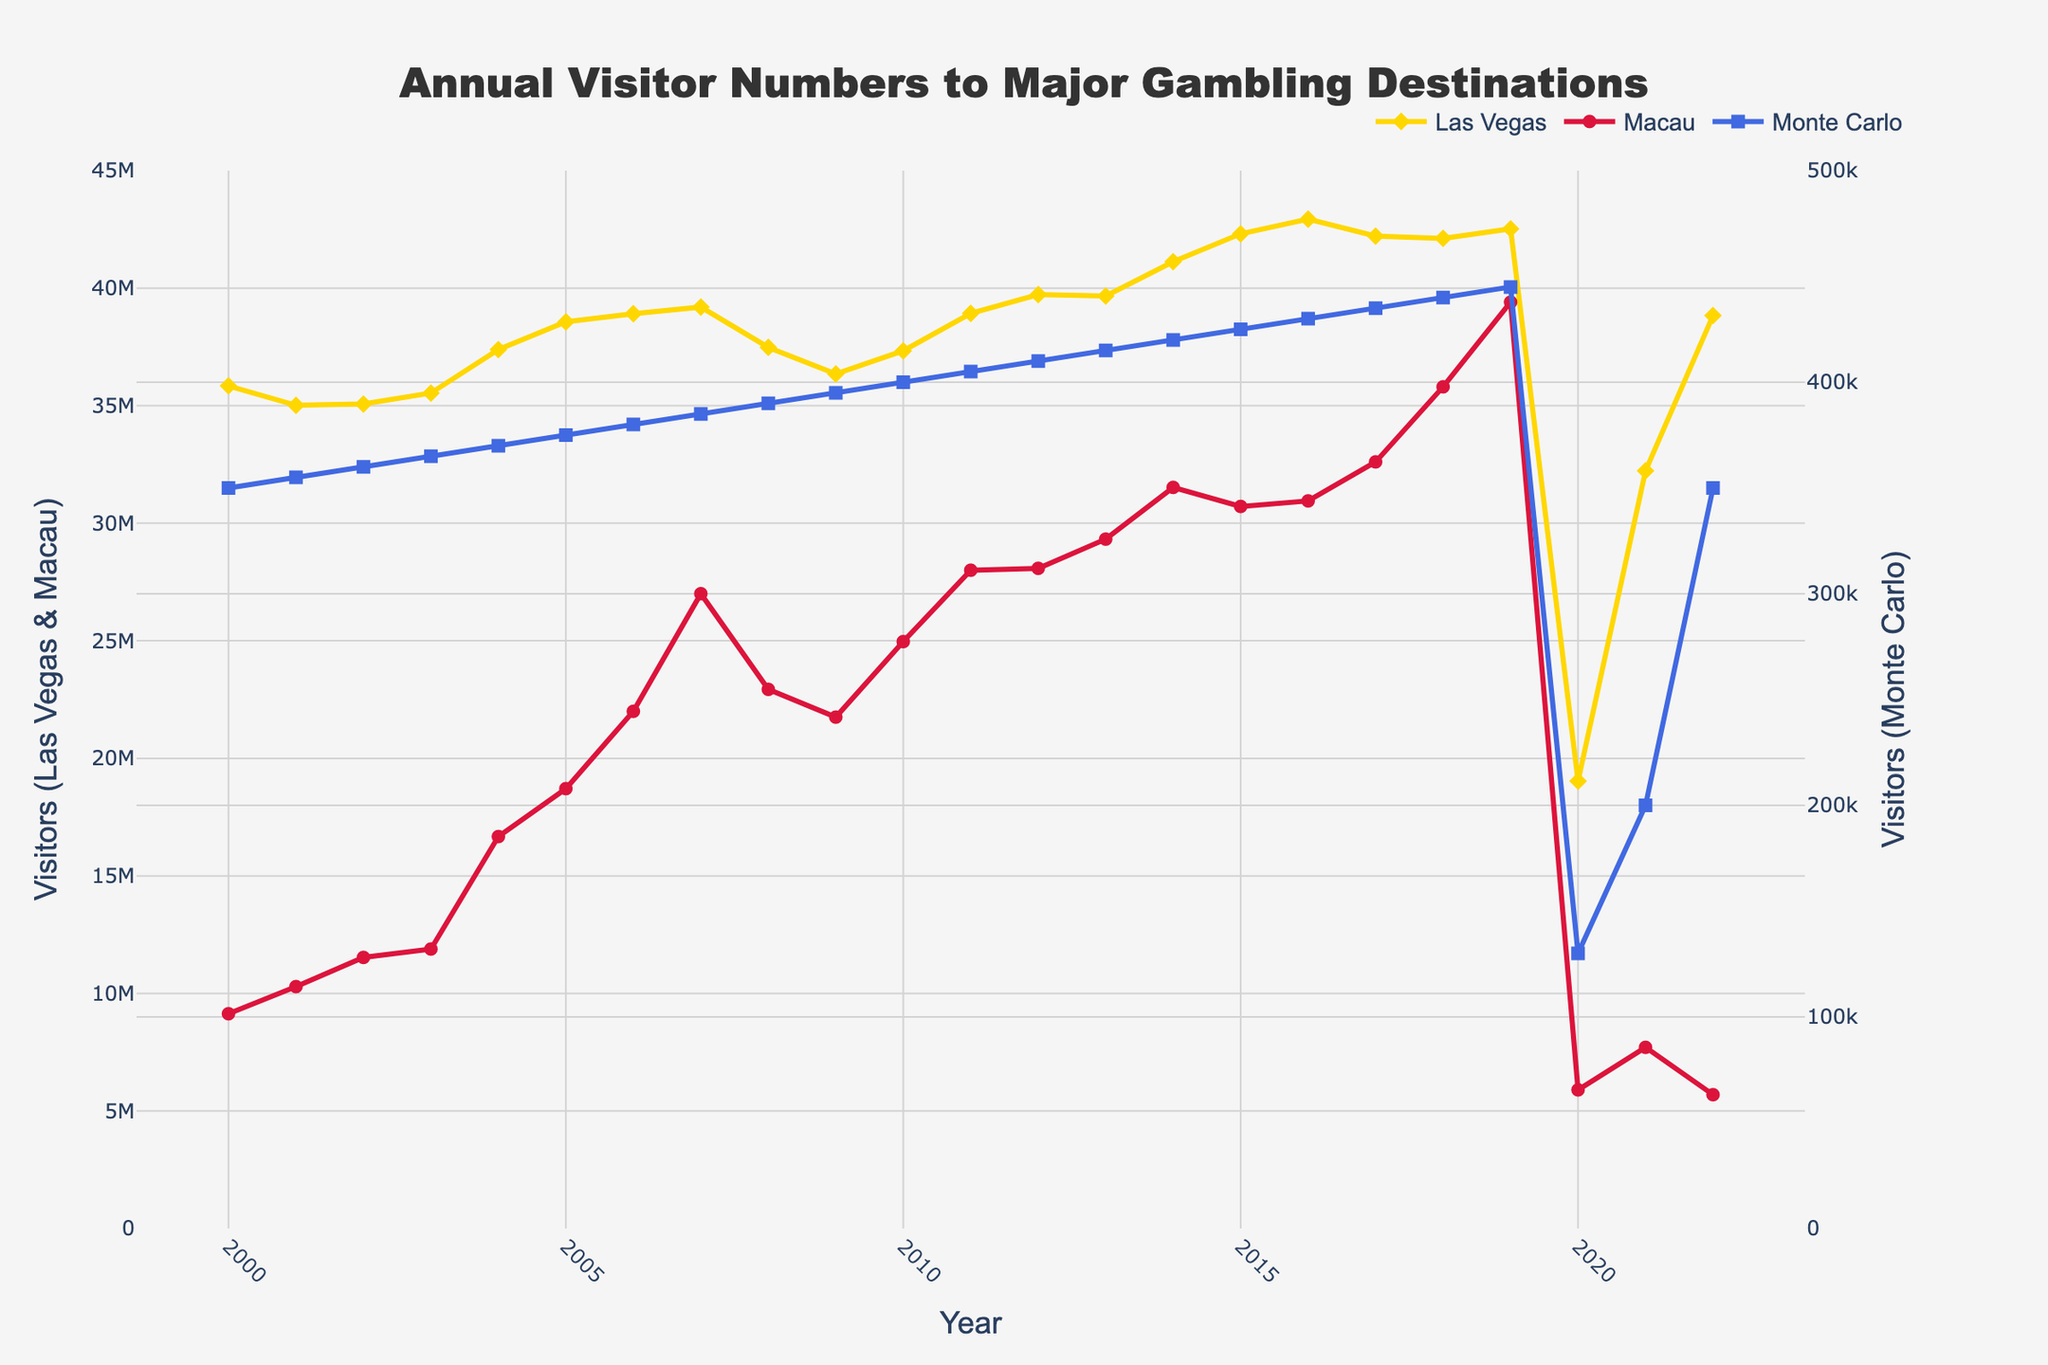What's the general trend of visitor numbers in Las Vegas from 2000 to 2022? To discern the trend, you need to look at how the data points for Las Vegas change over time. Despite fluctuations, the overall visitor numbers show an upward trend from 2000 to 2019, a sharp drop in 2020, and partial recovery afterward.
Answer: Upward Which destination had a peak visitor count in 2019? Examine the highest point each destination reaches on the line plot within the given years. Macau shows its peak with the highest visitor count in 2019.
Answer: Macau What year did Las Vegas experience a significant drop in visitor numbers, and what might have caused it? Inspect the Las Vegas line for a sharp downward spike. In 2020, there is a dramatic decline likely due to the COVID-19 pandemic.
Answer: 2020 How do the visitor numbers of Las Vegas and Macau in 2022 compare? Look at the endpoints of each line in 2022 for both destinations. Visitors to Las Vegas in 2022 were significantly higher than those to Macau.
Answer: Las Vegas was higher Calculate the total decline in visitor numbers for Las Vegas from 2019 to 2020. Subtract the visitor numbers in 2020 from those in 2019 for Las Vegas. The difference is 42,523,700 - 19,031,100 = 23,492,600.
Answer: 23,492,600 Between which two consecutive years did Macau have the largest increase in visitor numbers? Check the difference in visitor numbers between subsequent years for Macau. The largest increase is from 2006 to 2007.
Answer: 2006 to 2007 What is the pattern in the visitor numbers for Monte Carlo from 2000 to 2022? Observe the Monte Carlo line, which has a gradual increase and small fluctuations, peaking in 2019, then a sharp drop in 2020, followed by a small recovery.
Answer: Gradual increase, a peak in 2019, a sharp drop in 2020, slight recovery Compare the visitor numbers in Las Vegas and Monte Carlo in 2011. Look at the data points for both destinations in 2011. Las Vegas had significantly higher visitor numbers than Monte Carlo.
Answer: Las Vegas was higher In which year did Monte Carlo experience its lowest visitor count, and what might be the reason? Identify the lowest point on the Monte Carlo line, which is in 2020, likely due to the COVID-19 pandemic.
Answer: 2020 